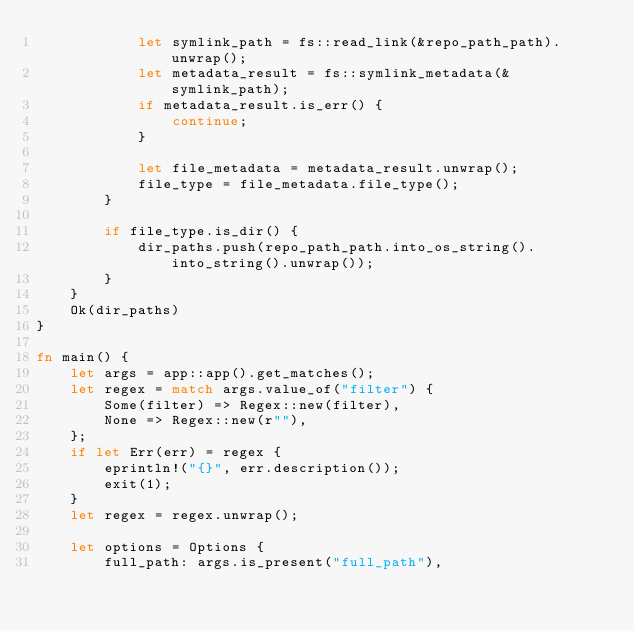Convert code to text. <code><loc_0><loc_0><loc_500><loc_500><_Rust_>            let symlink_path = fs::read_link(&repo_path_path).unwrap();
            let metadata_result = fs::symlink_metadata(&symlink_path);
            if metadata_result.is_err() {
                continue;
            }

            let file_metadata = metadata_result.unwrap();
            file_type = file_metadata.file_type();
        }

        if file_type.is_dir() {
            dir_paths.push(repo_path_path.into_os_string().into_string().unwrap());
        }
    }
    Ok(dir_paths)
}

fn main() {
    let args = app::app().get_matches();
    let regex = match args.value_of("filter") {
        Some(filter) => Regex::new(filter),
        None => Regex::new(r""),
    };
    if let Err(err) = regex {
        eprintln!("{}", err.description());
        exit(1);
    }
    let regex = regex.unwrap();

    let options = Options {
        full_path: args.is_present("full_path"),</code> 